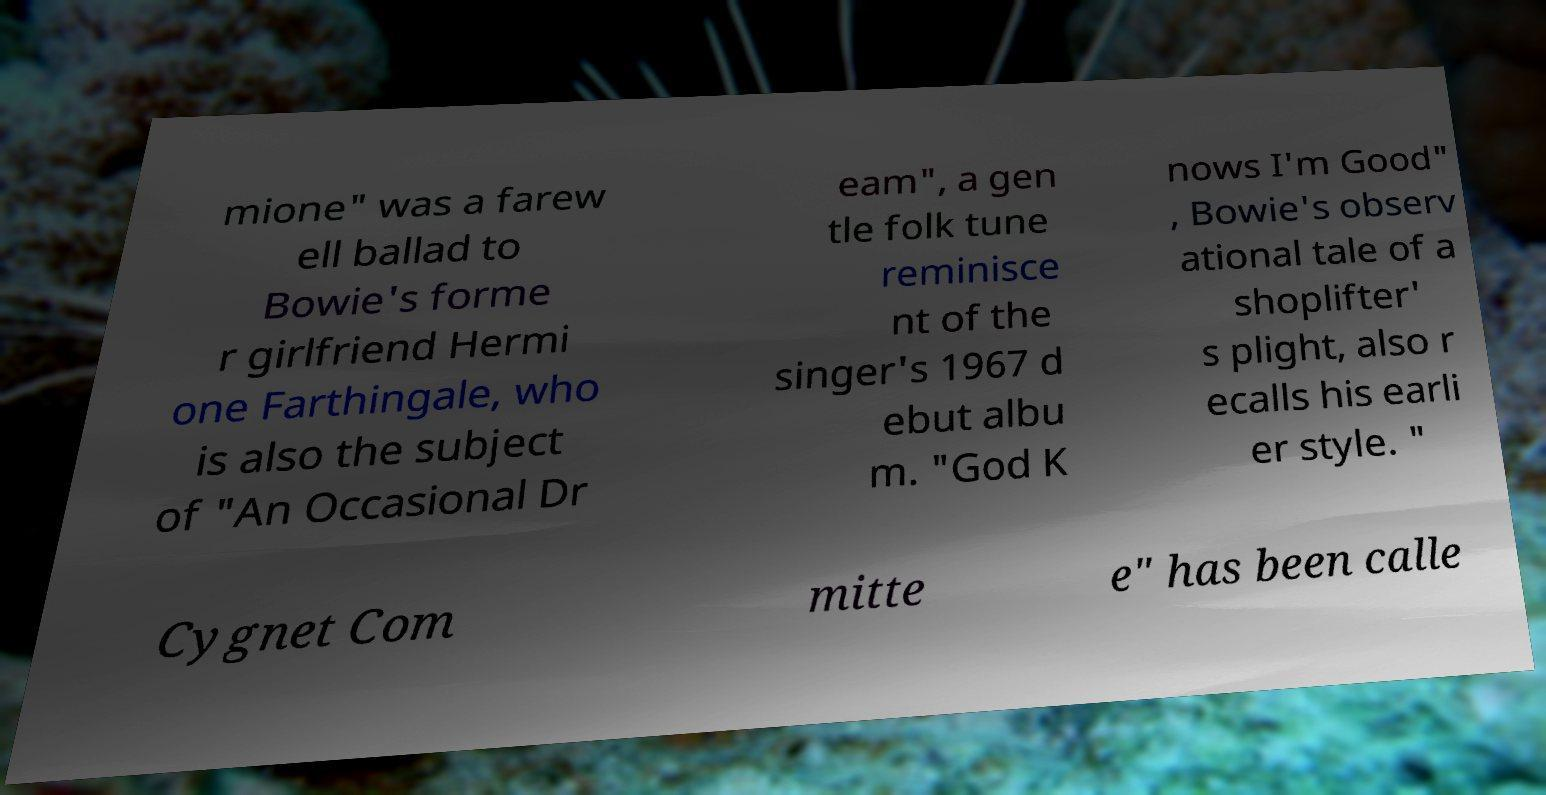Please read and relay the text visible in this image. What does it say? mione" was a farew ell ballad to Bowie's forme r girlfriend Hermi one Farthingale, who is also the subject of "An Occasional Dr eam", a gen tle folk tune reminisce nt of the singer's 1967 d ebut albu m. "God K nows I'm Good" , Bowie's observ ational tale of a shoplifter' s plight, also r ecalls his earli er style. " Cygnet Com mitte e" has been calle 